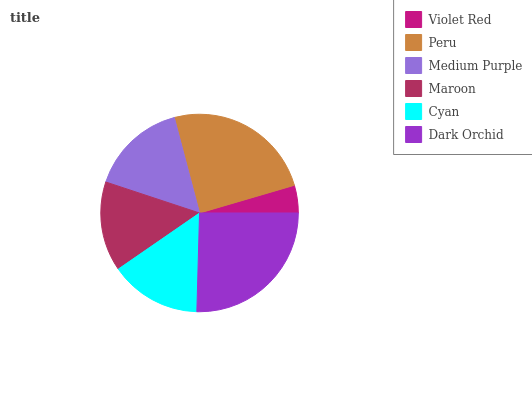Is Violet Red the minimum?
Answer yes or no. Yes. Is Dark Orchid the maximum?
Answer yes or no. Yes. Is Peru the minimum?
Answer yes or no. No. Is Peru the maximum?
Answer yes or no. No. Is Peru greater than Violet Red?
Answer yes or no. Yes. Is Violet Red less than Peru?
Answer yes or no. Yes. Is Violet Red greater than Peru?
Answer yes or no. No. Is Peru less than Violet Red?
Answer yes or no. No. Is Medium Purple the high median?
Answer yes or no. Yes. Is Cyan the low median?
Answer yes or no. Yes. Is Maroon the high median?
Answer yes or no. No. Is Peru the low median?
Answer yes or no. No. 